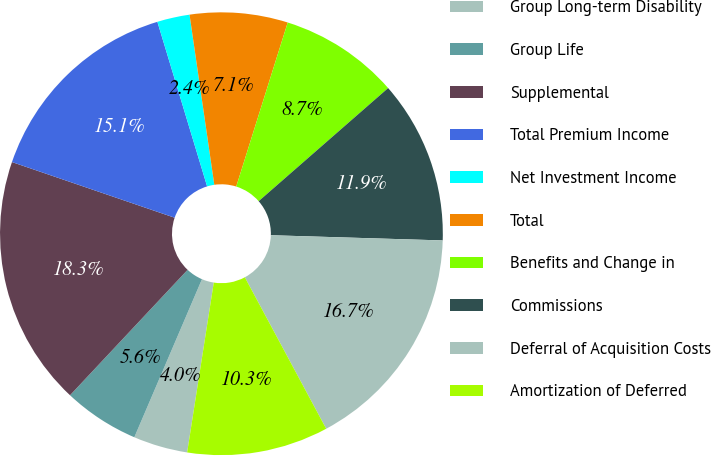Convert chart. <chart><loc_0><loc_0><loc_500><loc_500><pie_chart><fcel>Group Long-term Disability<fcel>Group Life<fcel>Supplemental<fcel>Total Premium Income<fcel>Net Investment Income<fcel>Total<fcel>Benefits and Change in<fcel>Commissions<fcel>Deferral of Acquisition Costs<fcel>Amortization of Deferred<nl><fcel>3.96%<fcel>5.55%<fcel>18.26%<fcel>15.08%<fcel>2.37%<fcel>7.14%<fcel>8.73%<fcel>11.91%<fcel>16.67%<fcel>10.32%<nl></chart> 